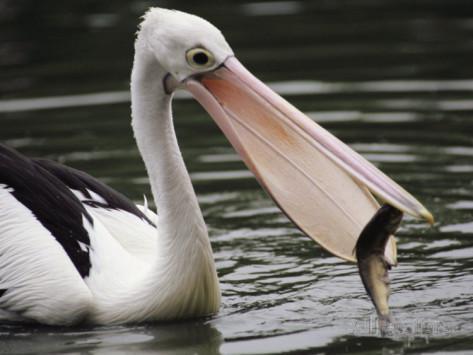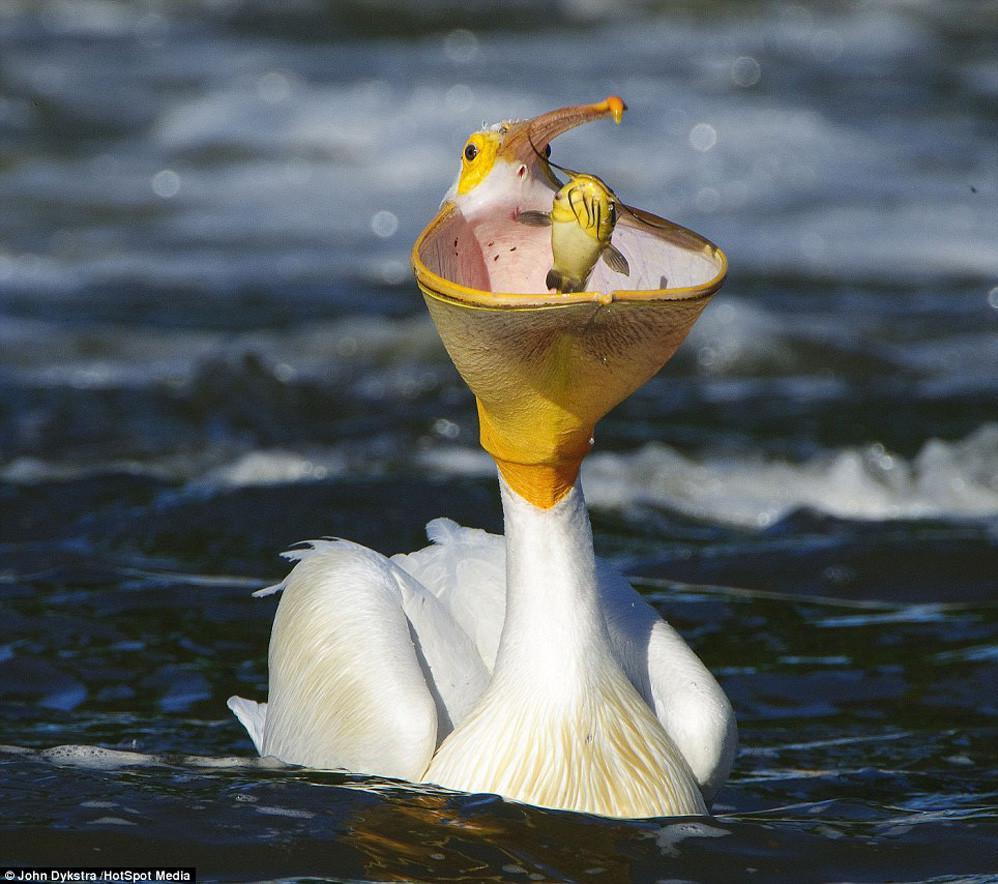The first image is the image on the left, the second image is the image on the right. Examine the images to the left and right. Is the description "The bird on the left has a fish, but there are no fish in the right image." accurate? Answer yes or no. No. 